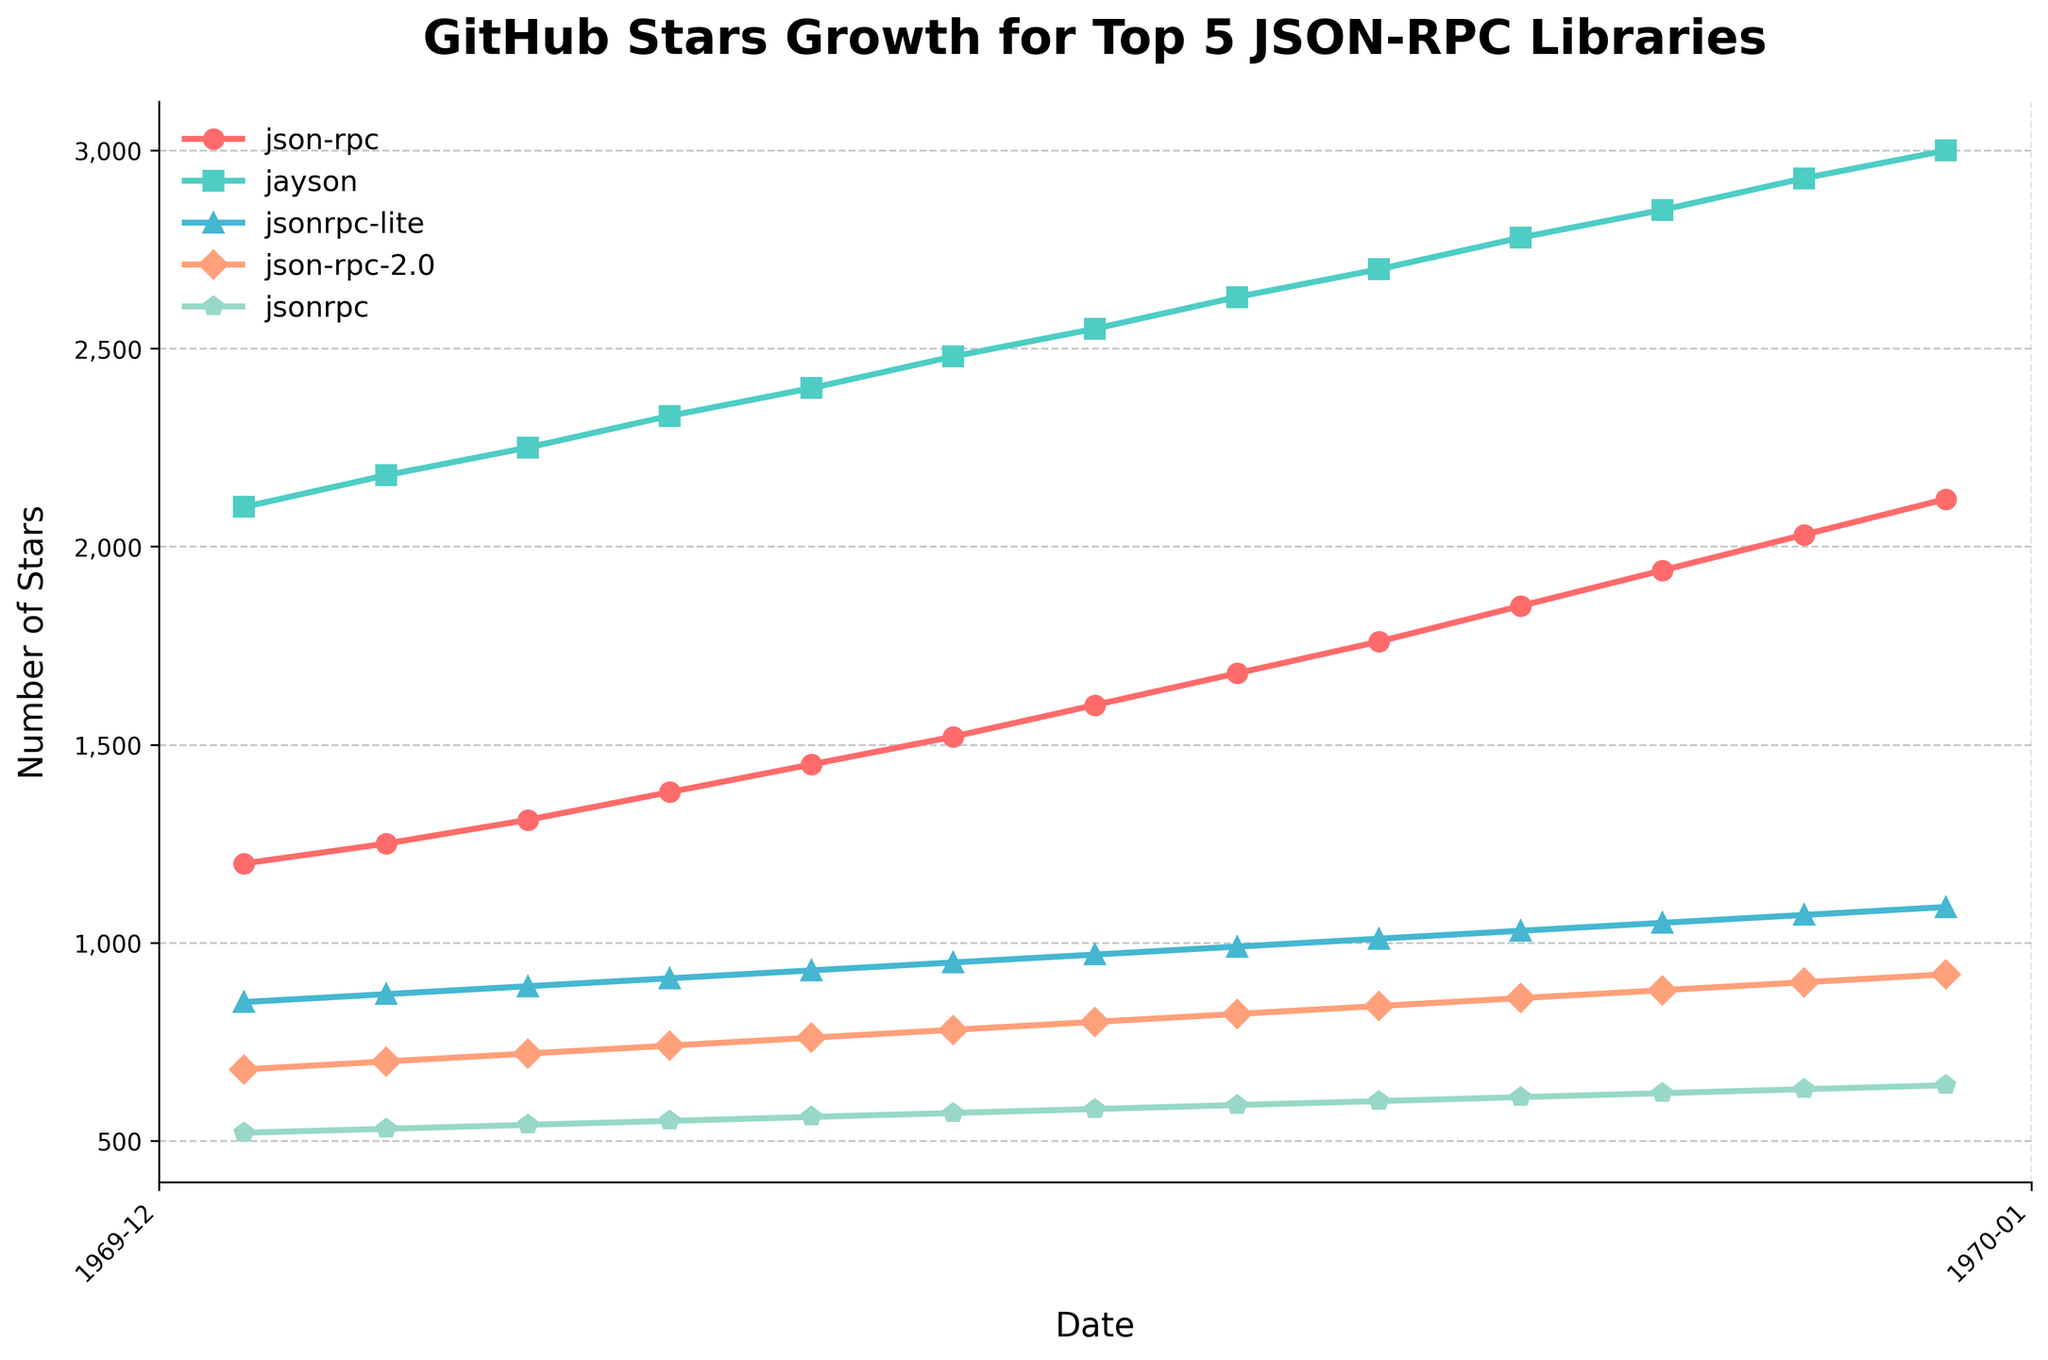What's the range of the number of stars for the "json-rpc" library between May 1, 2022, and May 1, 2023? The range can be calculated by subtracting the minimum number of stars from the maximum number of stars observed in the given period. On May 1, 2022, "json-rpc" had 1200 stars, and on May 1, 2023, it had 2120 stars. Thus, the range is 2120 - 1200.
Answer: 920 Which library had the highest number of stars in December 2022? By looking at the data points for December 2022 across all libraries, we find that "jayson" had the highest number of stars at 2630.
Answer: jayson How many more stars did "jsonrpc-lite" have than "json-rpc-2.0" in February 2023? In February 2023, "jsonrpc-lite" had 1030 stars, while "json-rpc-2.0" had 860 stars. The difference is 1030 - 860.
Answer: 170 On which dates did the "json-rpc" and "jayson" libraries have equal growth of 70 stars each? By tracking the growth month-by-month: 
For "json-rpc": 
- 1200 to 1250 (50), 1250 to 1310 (60), 1310 to 1380 (70), 1380 to 1450 (70), 1450 to 1520 (70), 1520 to 1600 (80), 1600 to 1680 (80), 1680 to 1760 (80), 1760 to 1850 (90), 1850 to 1940 (90), 1940 to 2030 (90), 2030 to 2120 (90).
For "jayson": 
- 2100 to 2180 (80), 2180 to 2250 (70), 2250 to 2330 (80), 2330 to 2400 (70), 2400 to 2480 (80), 2480 to 2550 (70), 2550 to 2630 (80), 2630 to 2700 (70), 2700 to 2780 (80), 2780 to 2850 (70), 2850 to 2930 (80), 2930 to 3000 (70). 
Only in July 2022, did both have exactly 70-star growth.
Answer: July 1, 2022 What is the average monthly growth of stars for the "jsonrpc" library over the one-year period? To find the average monthly growth, calculate the total increase in stars over the year and divide by the number of months. Starting from 520 stars in May 2022 and ending at 640 stars in May 2023, the total increase is 640 - 520, which is 120 stars. 
Thus, the average monthly growth = 120/12.
Answer: 10 Which library had the most significant single-month growth, and in which month did it occur? By examining the star counts, we can see the differences month-by-month for each library. For example, "json-rpc" grew by 90 stars from January 2023 to February 2023. After analyzing, the maximum single-month growth for any library is "jayson" from May 2022 (2100 stars) to June 2022 (2180 stars), a growth of 80 stars. The highest growth was "json-rpc" in April 2022 to May 2022, which gained 90 stars.
Answer: json-rpc, March 2023 Between November 2022 and January 2023, which library showed the consistent growth pattern, and what was the monthly growth rate? From the data, "json-rpc-2.0" shows consistent growth: 
- November 2022: 800 stars
- December 2022: 820 stars (+20 stars)
- January 2023: 840 stars (+20 stars)
Thus, the growth pattern for "json-rpc-2.0" was consistent at a rate of 20 stars per month.
Answer: json-rpc-2.0, 20 stars/month 